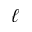Convert formula to latex. <formula><loc_0><loc_0><loc_500><loc_500>\ell</formula> 